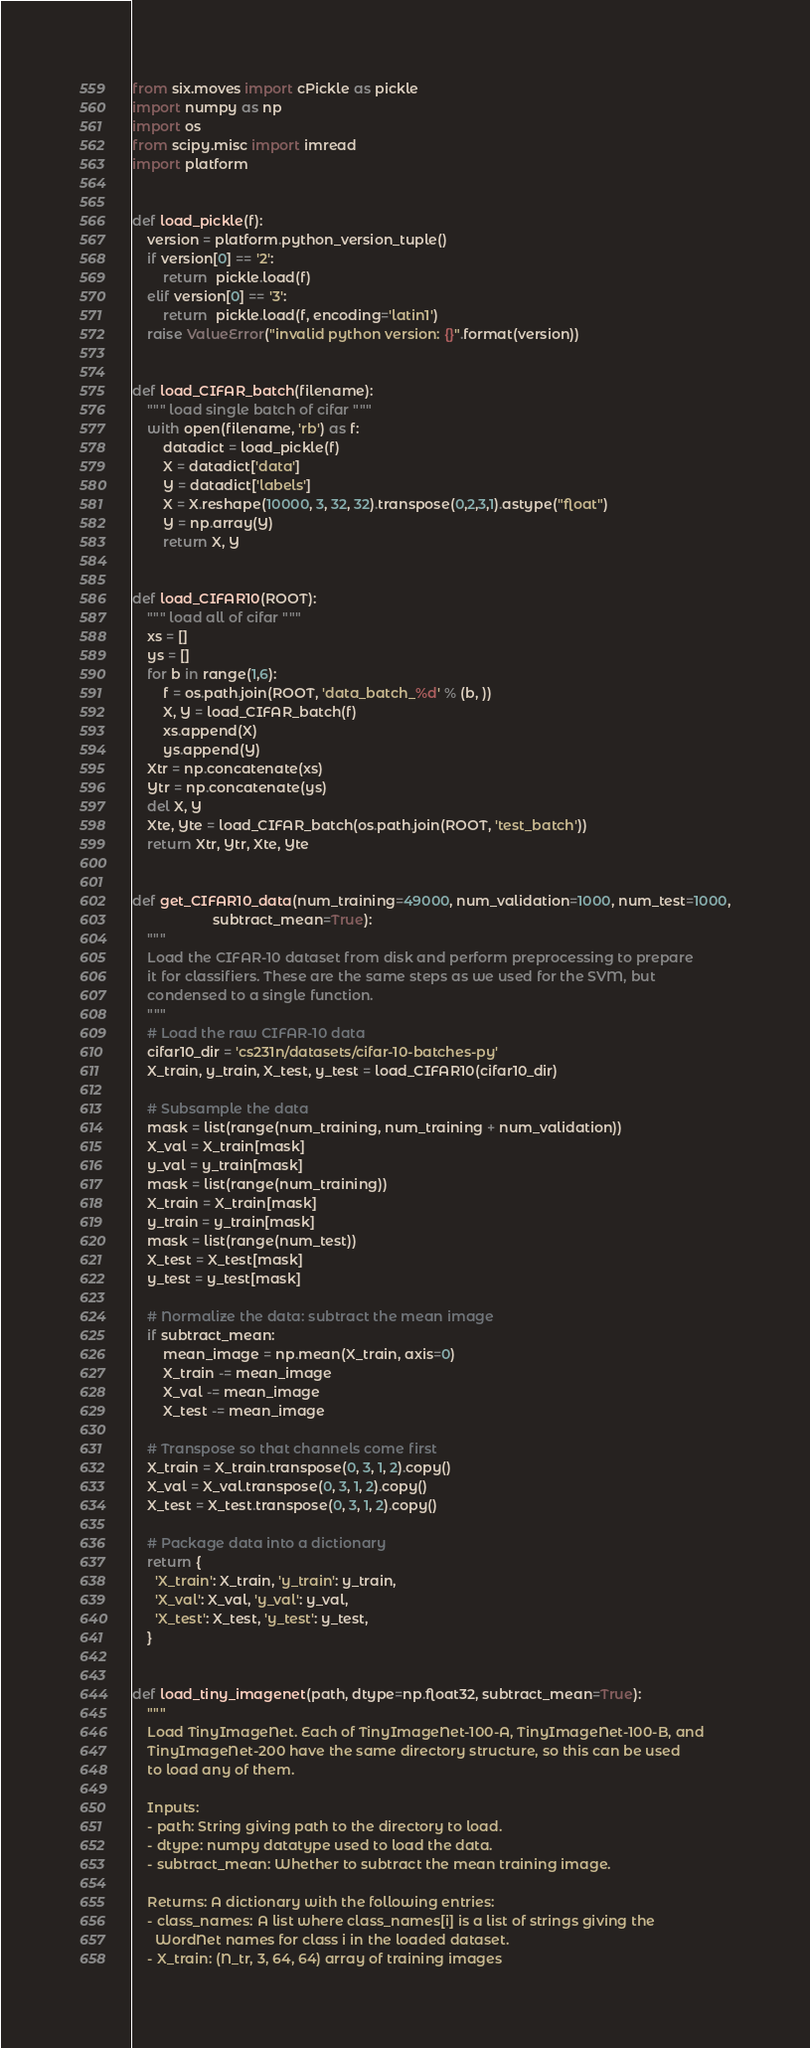Convert code to text. <code><loc_0><loc_0><loc_500><loc_500><_Python_>from six.moves import cPickle as pickle
import numpy as np
import os
from scipy.misc import imread
import platform


def load_pickle(f):
    version = platform.python_version_tuple()
    if version[0] == '2':
        return  pickle.load(f)
    elif version[0] == '3':
        return  pickle.load(f, encoding='latin1')
    raise ValueError("invalid python version: {}".format(version))

    
def load_CIFAR_batch(filename):
    """ load single batch of cifar """
    with open(filename, 'rb') as f:
        datadict = load_pickle(f)
        X = datadict['data']
        Y = datadict['labels']
        X = X.reshape(10000, 3, 32, 32).transpose(0,2,3,1).astype("float")
        Y = np.array(Y)
        return X, Y

    
def load_CIFAR10(ROOT):
    """ load all of cifar """
    xs = []
    ys = []
    for b in range(1,6):
        f = os.path.join(ROOT, 'data_batch_%d' % (b, ))
        X, Y = load_CIFAR_batch(f)
        xs.append(X)
        ys.append(Y)
    Xtr = np.concatenate(xs)
    Ytr = np.concatenate(ys)
    del X, Y
    Xte, Yte = load_CIFAR_batch(os.path.join(ROOT, 'test_batch'))
    return Xtr, Ytr, Xte, Yte


def get_CIFAR10_data(num_training=49000, num_validation=1000, num_test=1000,
                     subtract_mean=True):
    """
    Load the CIFAR-10 dataset from disk and perform preprocessing to prepare
    it for classifiers. These are the same steps as we used for the SVM, but
    condensed to a single function.
    """
    # Load the raw CIFAR-10 data
    cifar10_dir = 'cs231n/datasets/cifar-10-batches-py'
    X_train, y_train, X_test, y_test = load_CIFAR10(cifar10_dir)

    # Subsample the data
    mask = list(range(num_training, num_training + num_validation))
    X_val = X_train[mask]
    y_val = y_train[mask]
    mask = list(range(num_training))
    X_train = X_train[mask]
    y_train = y_train[mask]
    mask = list(range(num_test))
    X_test = X_test[mask]
    y_test = y_test[mask]

    # Normalize the data: subtract the mean image
    if subtract_mean:
        mean_image = np.mean(X_train, axis=0)
        X_train -= mean_image
        X_val -= mean_image
        X_test -= mean_image

    # Transpose so that channels come first
    X_train = X_train.transpose(0, 3, 1, 2).copy()
    X_val = X_val.transpose(0, 3, 1, 2).copy()
    X_test = X_test.transpose(0, 3, 1, 2).copy()

    # Package data into a dictionary
    return {
      'X_train': X_train, 'y_train': y_train,
      'X_val': X_val, 'y_val': y_val,
      'X_test': X_test, 'y_test': y_test,
    }


def load_tiny_imagenet(path, dtype=np.float32, subtract_mean=True):
    """
    Load TinyImageNet. Each of TinyImageNet-100-A, TinyImageNet-100-B, and
    TinyImageNet-200 have the same directory structure, so this can be used
    to load any of them.

    Inputs:
    - path: String giving path to the directory to load.
    - dtype: numpy datatype used to load the data.
    - subtract_mean: Whether to subtract the mean training image.

    Returns: A dictionary with the following entries:
    - class_names: A list where class_names[i] is a list of strings giving the
      WordNet names for class i in the loaded dataset.
    - X_train: (N_tr, 3, 64, 64) array of training images</code> 